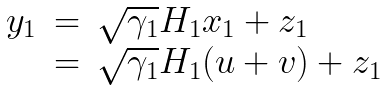<formula> <loc_0><loc_0><loc_500><loc_500>\begin{array} { l l l } y _ { 1 } & = & \sqrt { \gamma _ { 1 } } H _ { 1 } x _ { 1 } + z _ { 1 } \\ & = & \sqrt { \gamma _ { 1 } } H _ { 1 } ( u + v ) + z _ { 1 } \end{array}</formula> 